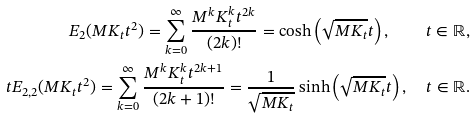<formula> <loc_0><loc_0><loc_500><loc_500>E _ { 2 } ( M K _ { t } t ^ { 2 } ) = \sum _ { k = 0 } ^ { \infty } \frac { M ^ { k } K ^ { k } _ { t } t ^ { 2 k } } { ( 2 k ) ! } = \cosh \left ( \sqrt { M K _ { t } } t \right ) , \quad t \in \mathbb { R } , \\ t E _ { 2 , 2 } ( M K _ { t } t ^ { 2 } ) = \sum _ { k = 0 } ^ { \infty } \frac { M ^ { k } K ^ { k } _ { t } t ^ { 2 k + 1 } } { ( 2 k + 1 ) ! } = \frac { 1 } { \sqrt { M K _ { t } } } \sinh \left ( \sqrt { M K _ { t } } t \right ) , \quad t \in \mathbb { R } .</formula> 